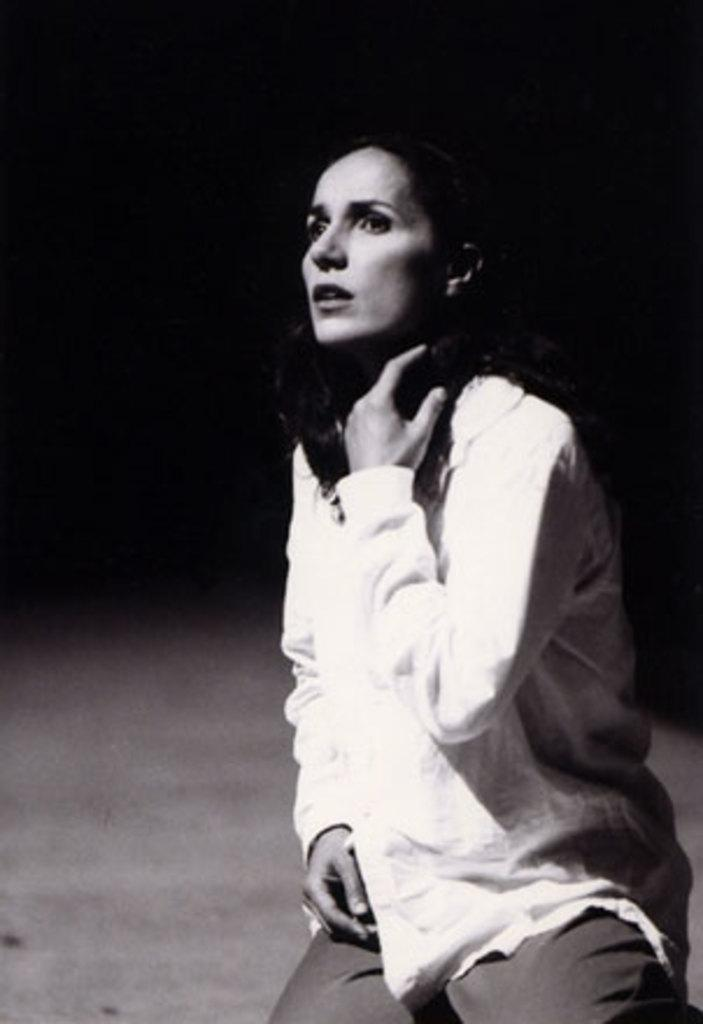What is the main subject in the foreground of the image? There is a woman in the foreground of the image. Can you describe the background of the image? The background of the image is blurred. What type of cannon is being used to sort the paste in the image? There is no cannon or paste present in the image. 